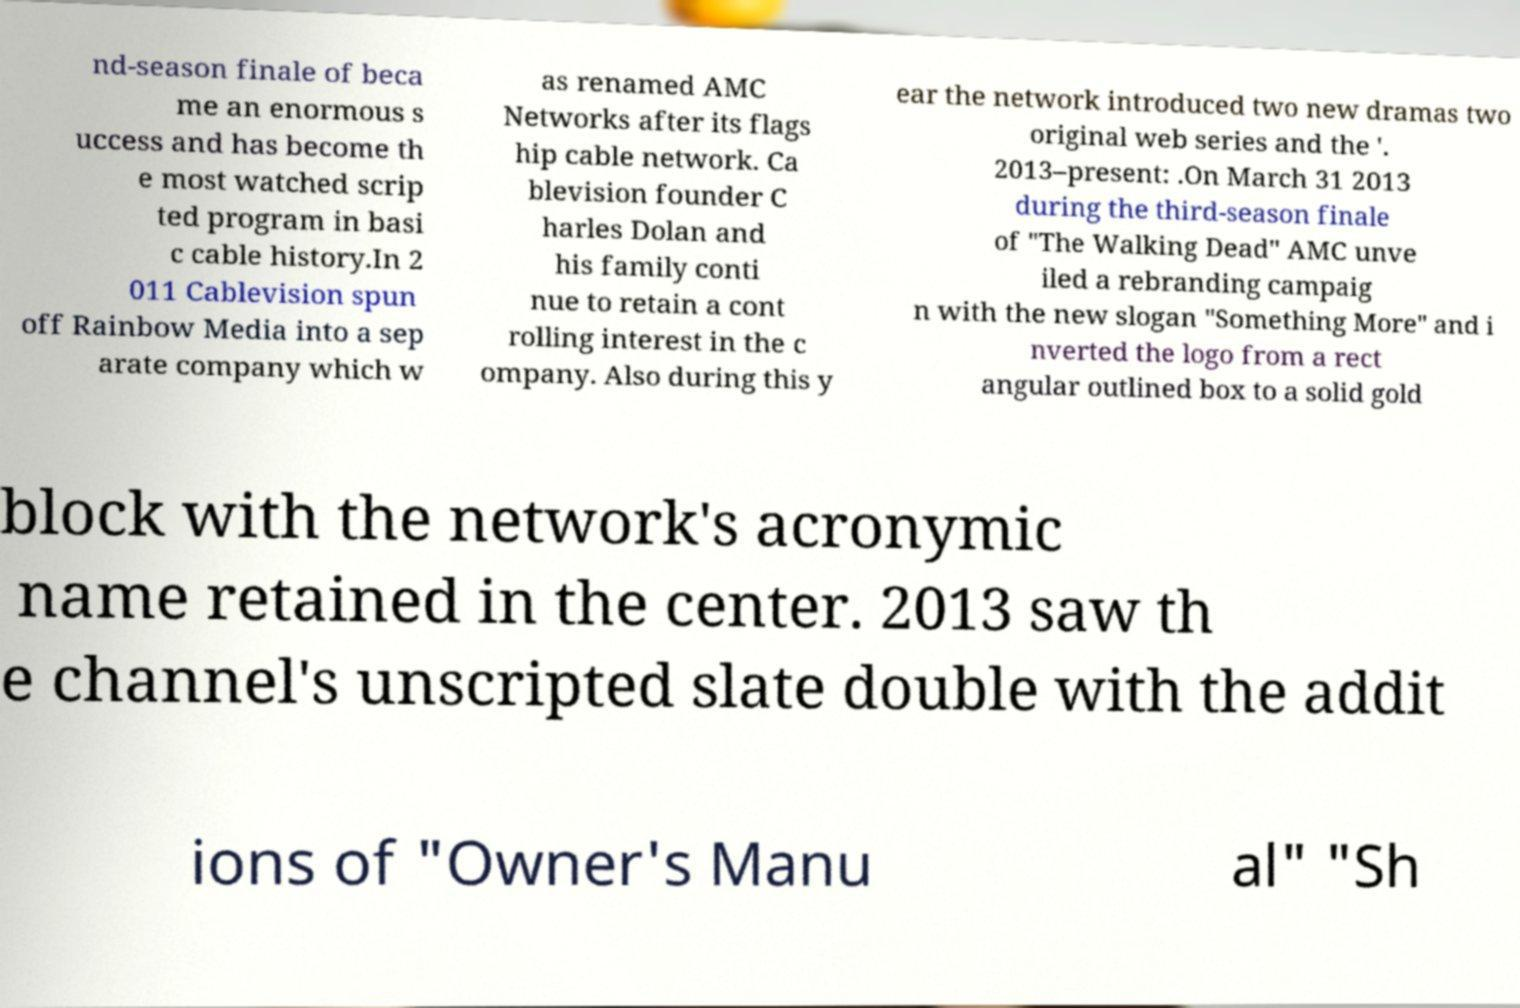There's text embedded in this image that I need extracted. Can you transcribe it verbatim? nd-season finale of beca me an enormous s uccess and has become th e most watched scrip ted program in basi c cable history.In 2 011 Cablevision spun off Rainbow Media into a sep arate company which w as renamed AMC Networks after its flags hip cable network. Ca blevision founder C harles Dolan and his family conti nue to retain a cont rolling interest in the c ompany. Also during this y ear the network introduced two new dramas two original web series and the '. 2013–present: .On March 31 2013 during the third-season finale of "The Walking Dead" AMC unve iled a rebranding campaig n with the new slogan "Something More" and i nverted the logo from a rect angular outlined box to a solid gold block with the network's acronymic name retained in the center. 2013 saw th e channel's unscripted slate double with the addit ions of "Owner's Manu al" "Sh 